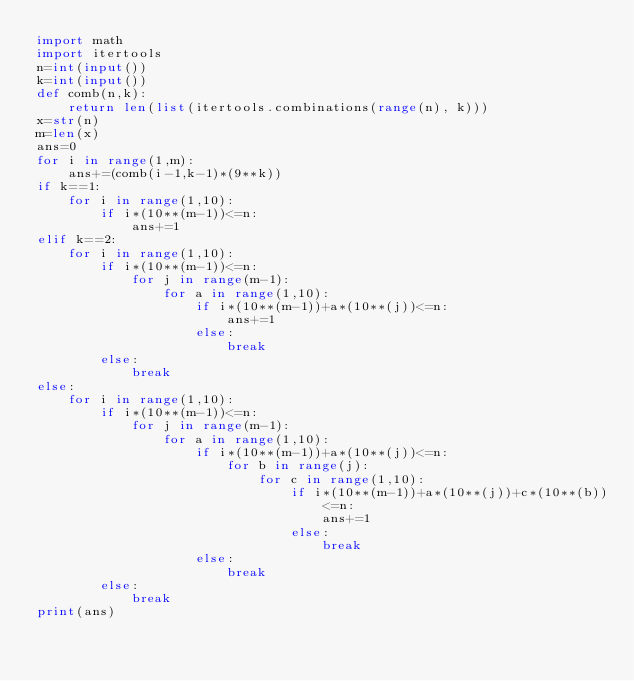Convert code to text. <code><loc_0><loc_0><loc_500><loc_500><_Python_>import math
import itertools
n=int(input())
k=int(input())
def comb(n,k):
    return len(list(itertools.combinations(range(n), k)))
x=str(n)
m=len(x)
ans=0
for i in range(1,m):
    ans+=(comb(i-1,k-1)*(9**k))
if k==1:
    for i in range(1,10):
        if i*(10**(m-1))<=n:
            ans+=1
elif k==2:
    for i in range(1,10):
        if i*(10**(m-1))<=n:
            for j in range(m-1):
                for a in range(1,10):
                    if i*(10**(m-1))+a*(10**(j))<=n:
                        ans+=1
                    else:
                        break
        else:
            break
else:
    for i in range(1,10):
        if i*(10**(m-1))<=n:
            for j in range(m-1):
                for a in range(1,10):
                    if i*(10**(m-1))+a*(10**(j))<=n:
                        for b in range(j):
                            for c in range(1,10):
                                if i*(10**(m-1))+a*(10**(j))+c*(10**(b))<=n:
                                    ans+=1
                                else:
                                    break
                    else:
                        break
        else:
            break
print(ans)
</code> 